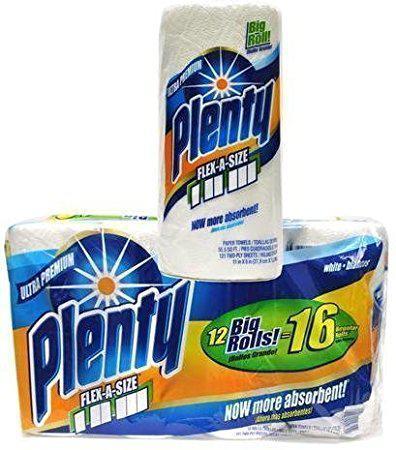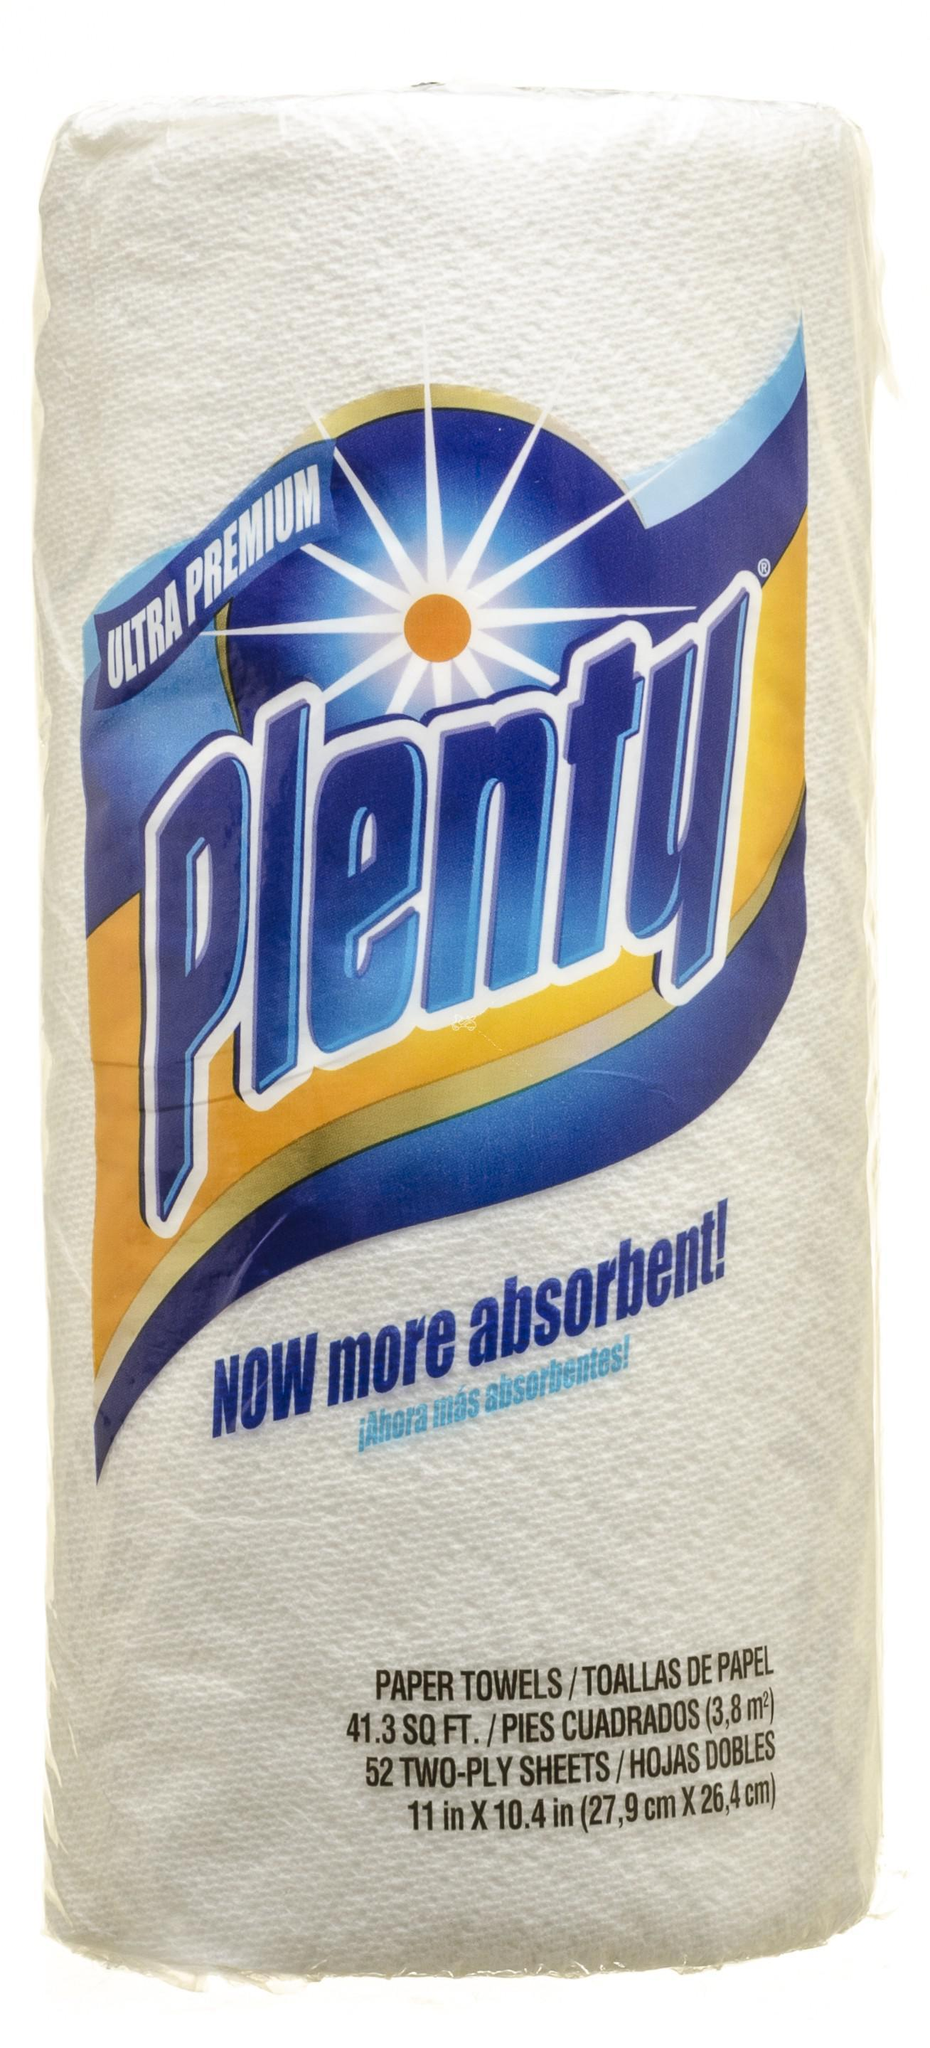The first image is the image on the left, the second image is the image on the right. For the images shown, is this caption "The lefthand image contains one wrapped multi-roll of towels, and the right image shows one upright roll." true? Answer yes or no. No. The first image is the image on the left, the second image is the image on the right. Given the left and right images, does the statement "One picture shows one pack of paper towels, while the other shows only a single roll of paper towels." hold true? Answer yes or no. No. 